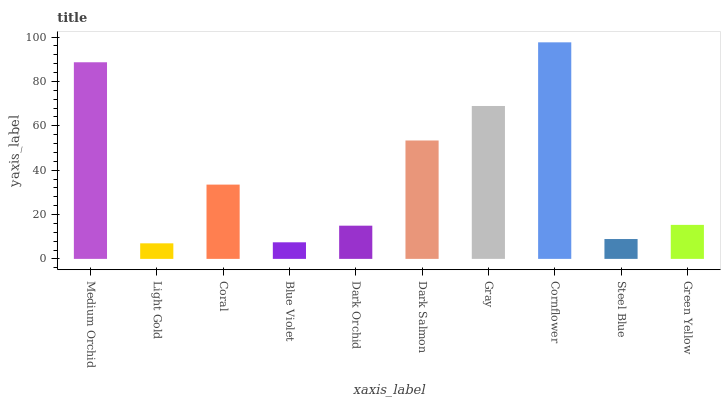Is Light Gold the minimum?
Answer yes or no. Yes. Is Cornflower the maximum?
Answer yes or no. Yes. Is Coral the minimum?
Answer yes or no. No. Is Coral the maximum?
Answer yes or no. No. Is Coral greater than Light Gold?
Answer yes or no. Yes. Is Light Gold less than Coral?
Answer yes or no. Yes. Is Light Gold greater than Coral?
Answer yes or no. No. Is Coral less than Light Gold?
Answer yes or no. No. Is Coral the high median?
Answer yes or no. Yes. Is Green Yellow the low median?
Answer yes or no. Yes. Is Light Gold the high median?
Answer yes or no. No. Is Medium Orchid the low median?
Answer yes or no. No. 